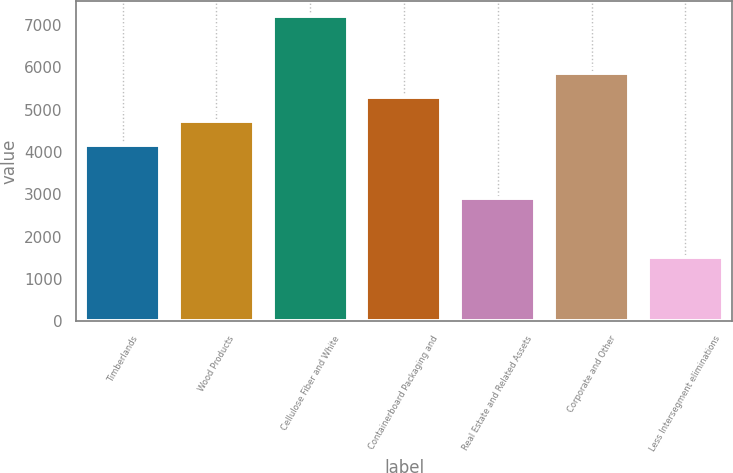Convert chart. <chart><loc_0><loc_0><loc_500><loc_500><bar_chart><fcel>Timberlands<fcel>Wood Products<fcel>Cellulose Fiber and White<fcel>Containerboard Packaging and<fcel>Real Estate and Related Assets<fcel>Corporate and Other<fcel>Less Intersegment eliminations<nl><fcel>4169<fcel>4737.9<fcel>7216<fcel>5309<fcel>2907<fcel>5877.9<fcel>1527<nl></chart> 